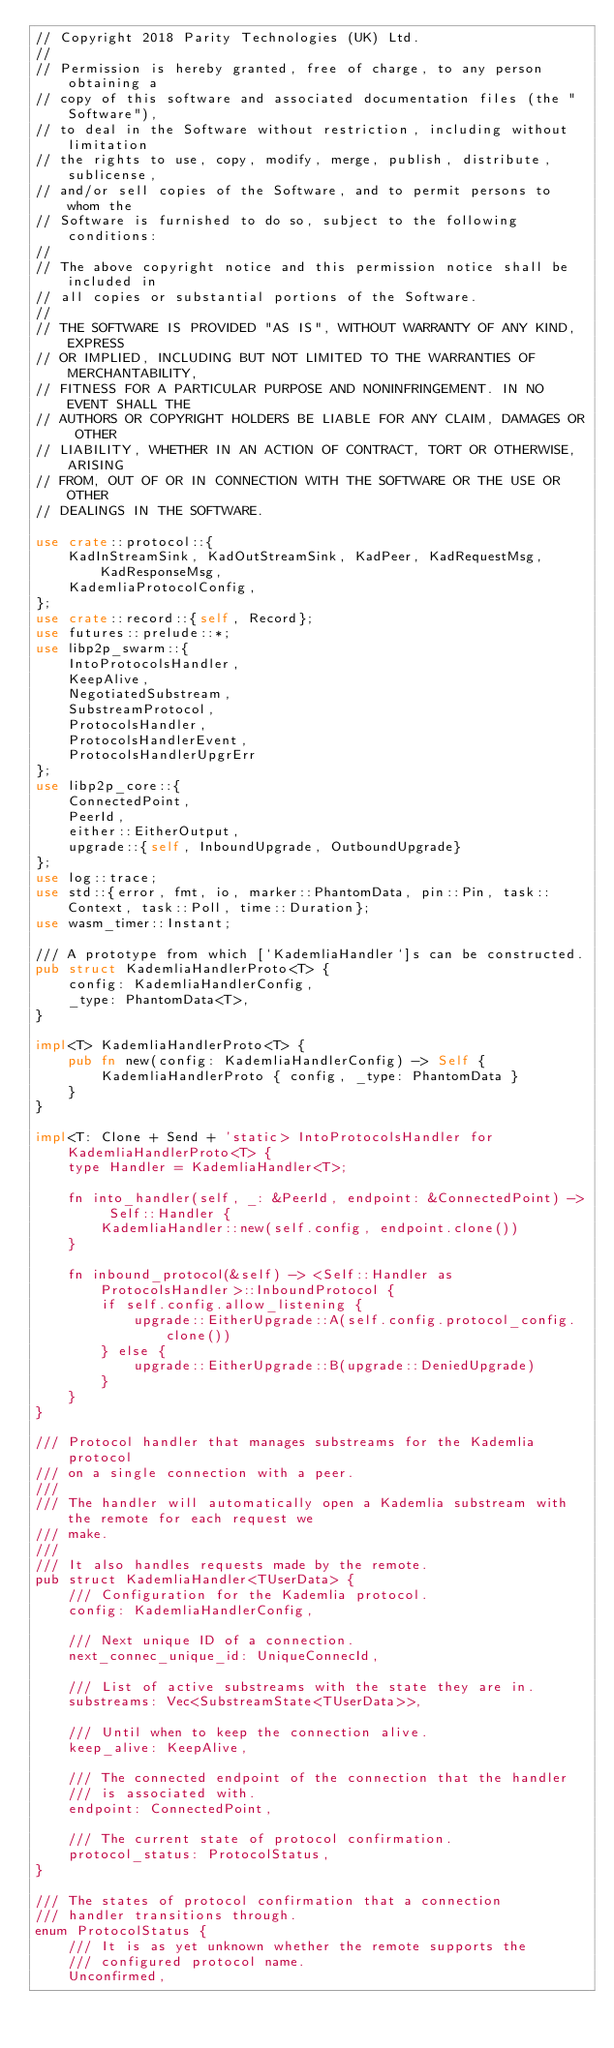Convert code to text. <code><loc_0><loc_0><loc_500><loc_500><_Rust_>// Copyright 2018 Parity Technologies (UK) Ltd.
//
// Permission is hereby granted, free of charge, to any person obtaining a
// copy of this software and associated documentation files (the "Software"),
// to deal in the Software without restriction, including without limitation
// the rights to use, copy, modify, merge, publish, distribute, sublicense,
// and/or sell copies of the Software, and to permit persons to whom the
// Software is furnished to do so, subject to the following conditions:
//
// The above copyright notice and this permission notice shall be included in
// all copies or substantial portions of the Software.
//
// THE SOFTWARE IS PROVIDED "AS IS", WITHOUT WARRANTY OF ANY KIND, EXPRESS
// OR IMPLIED, INCLUDING BUT NOT LIMITED TO THE WARRANTIES OF MERCHANTABILITY,
// FITNESS FOR A PARTICULAR PURPOSE AND NONINFRINGEMENT. IN NO EVENT SHALL THE
// AUTHORS OR COPYRIGHT HOLDERS BE LIABLE FOR ANY CLAIM, DAMAGES OR OTHER
// LIABILITY, WHETHER IN AN ACTION OF CONTRACT, TORT OR OTHERWISE, ARISING
// FROM, OUT OF OR IN CONNECTION WITH THE SOFTWARE OR THE USE OR OTHER
// DEALINGS IN THE SOFTWARE.

use crate::protocol::{
    KadInStreamSink, KadOutStreamSink, KadPeer, KadRequestMsg, KadResponseMsg,
    KademliaProtocolConfig,
};
use crate::record::{self, Record};
use futures::prelude::*;
use libp2p_swarm::{
    IntoProtocolsHandler,
    KeepAlive,
    NegotiatedSubstream,
    SubstreamProtocol,
    ProtocolsHandler,
    ProtocolsHandlerEvent,
    ProtocolsHandlerUpgrErr
};
use libp2p_core::{
    ConnectedPoint,
    PeerId,
    either::EitherOutput,
    upgrade::{self, InboundUpgrade, OutboundUpgrade}
};
use log::trace;
use std::{error, fmt, io, marker::PhantomData, pin::Pin, task::Context, task::Poll, time::Duration};
use wasm_timer::Instant;

/// A prototype from which [`KademliaHandler`]s can be constructed.
pub struct KademliaHandlerProto<T> {
    config: KademliaHandlerConfig,
    _type: PhantomData<T>,
}

impl<T> KademliaHandlerProto<T> {
    pub fn new(config: KademliaHandlerConfig) -> Self {
        KademliaHandlerProto { config, _type: PhantomData }
    }
}

impl<T: Clone + Send + 'static> IntoProtocolsHandler for KademliaHandlerProto<T> {
    type Handler = KademliaHandler<T>;

    fn into_handler(self, _: &PeerId, endpoint: &ConnectedPoint) -> Self::Handler {
        KademliaHandler::new(self.config, endpoint.clone())
    }

    fn inbound_protocol(&self) -> <Self::Handler as ProtocolsHandler>::InboundProtocol {
        if self.config.allow_listening {
            upgrade::EitherUpgrade::A(self.config.protocol_config.clone())
        } else {
            upgrade::EitherUpgrade::B(upgrade::DeniedUpgrade)
        }
    }
}

/// Protocol handler that manages substreams for the Kademlia protocol
/// on a single connection with a peer.
///
/// The handler will automatically open a Kademlia substream with the remote for each request we
/// make.
///
/// It also handles requests made by the remote.
pub struct KademliaHandler<TUserData> {
    /// Configuration for the Kademlia protocol.
    config: KademliaHandlerConfig,

    /// Next unique ID of a connection.
    next_connec_unique_id: UniqueConnecId,

    /// List of active substreams with the state they are in.
    substreams: Vec<SubstreamState<TUserData>>,

    /// Until when to keep the connection alive.
    keep_alive: KeepAlive,

    /// The connected endpoint of the connection that the handler
    /// is associated with.
    endpoint: ConnectedPoint,

    /// The current state of protocol confirmation.
    protocol_status: ProtocolStatus,
}

/// The states of protocol confirmation that a connection
/// handler transitions through.
enum ProtocolStatus {
    /// It is as yet unknown whether the remote supports the
    /// configured protocol name.
    Unconfirmed,</code> 